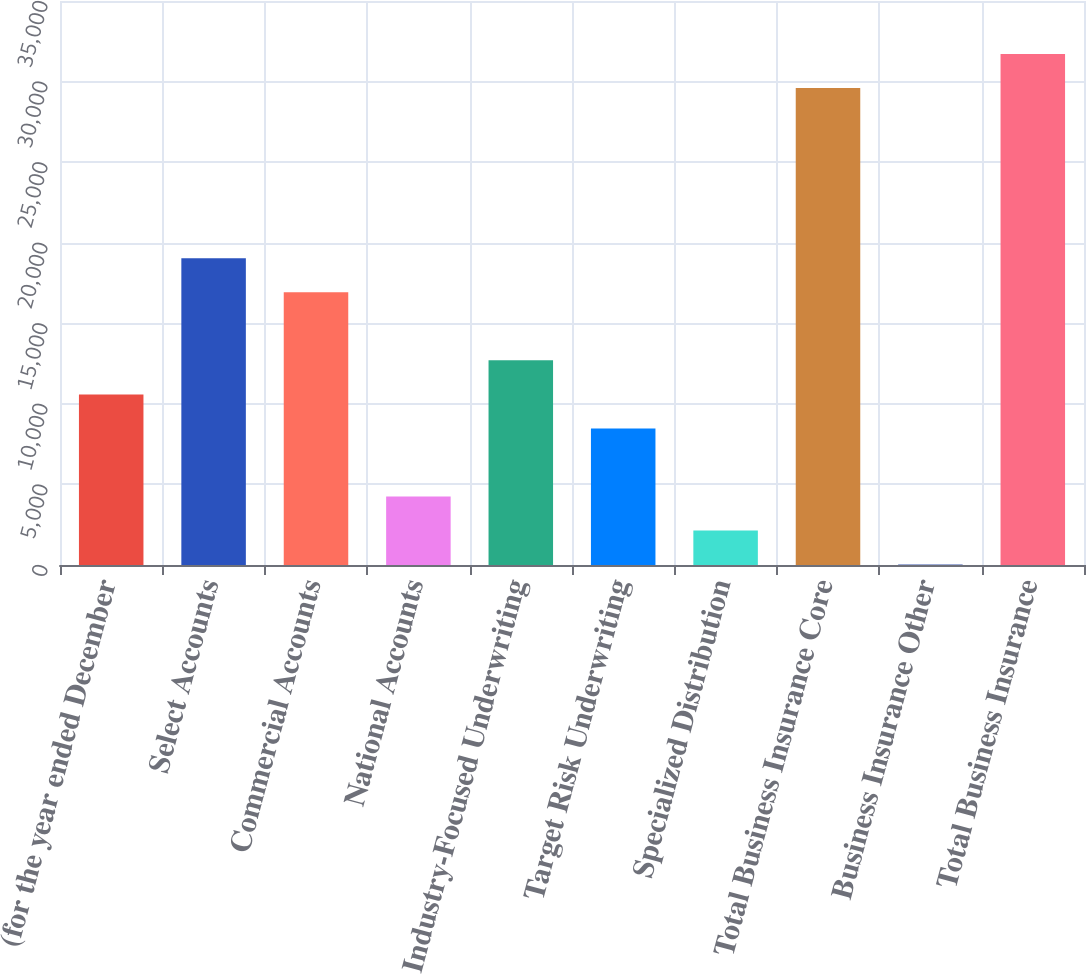Convert chart. <chart><loc_0><loc_0><loc_500><loc_500><bar_chart><fcel>(for the year ended December<fcel>Select Accounts<fcel>Commercial Accounts<fcel>National Accounts<fcel>Industry-Focused Underwriting<fcel>Target Risk Underwriting<fcel>Specialized Distribution<fcel>Total Business Insurance Core<fcel>Business Insurance Other<fcel>Total Business Insurance<nl><fcel>10587.5<fcel>19037.5<fcel>16925<fcel>4250<fcel>12700<fcel>8475<fcel>2137.5<fcel>29600<fcel>25<fcel>31712.5<nl></chart> 